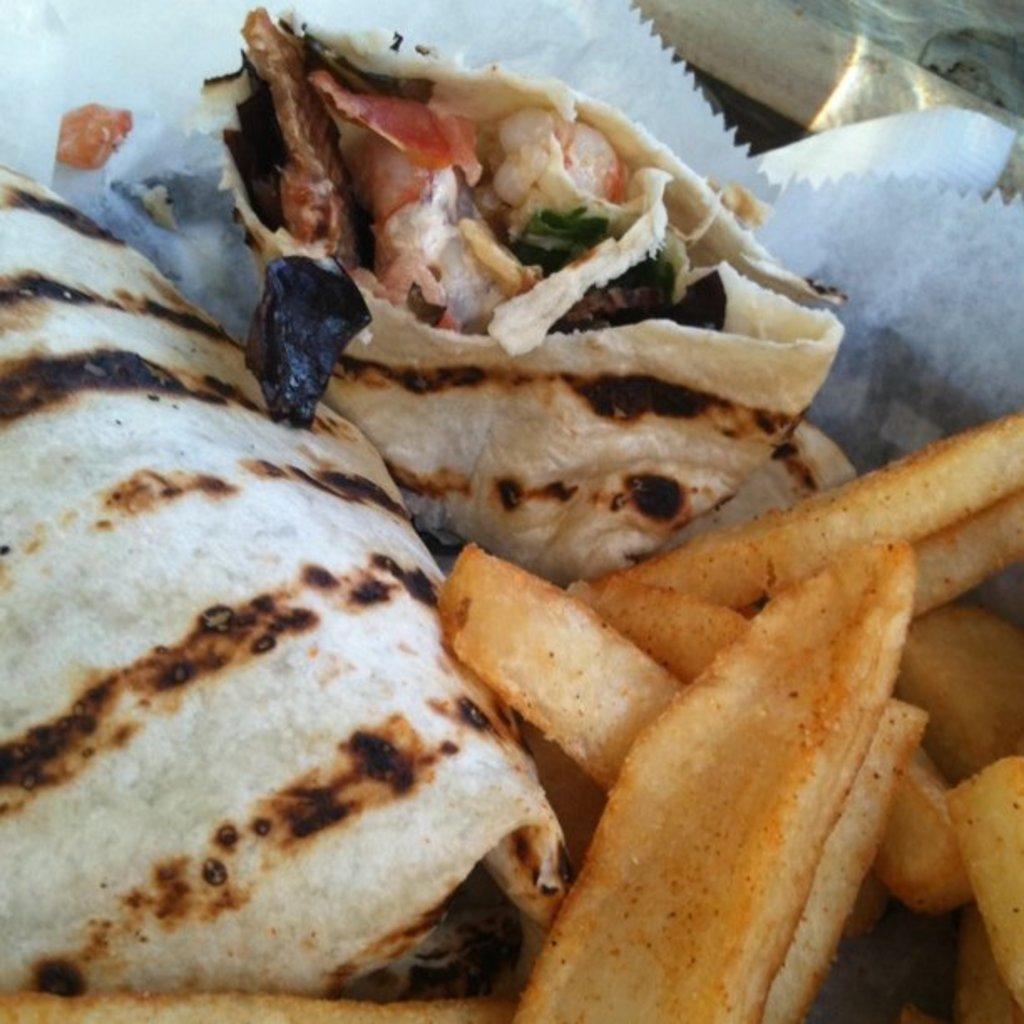What is present on the paper plate in the image? There is food in a paper plate in the image. What is the national anthem of the nation depicted in the image? There is no nation depicted in the image, as it only shows food on a paper plate. How does the food on the paper plate relate to impulse control? The image does not provide any information about impulse control or the context in which the food is being consumed. 